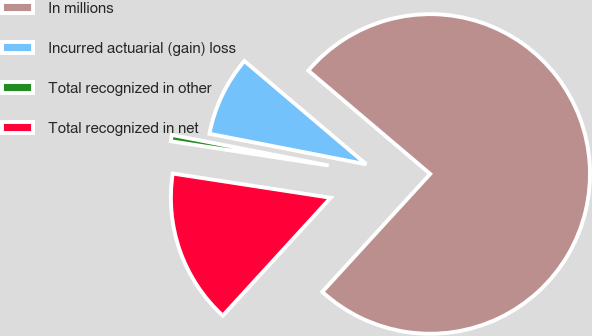Convert chart to OTSL. <chart><loc_0><loc_0><loc_500><loc_500><pie_chart><fcel>In millions<fcel>Incurred actuarial (gain) loss<fcel>Total recognized in other<fcel>Total recognized in net<nl><fcel>75.6%<fcel>8.13%<fcel>0.64%<fcel>15.63%<nl></chart> 